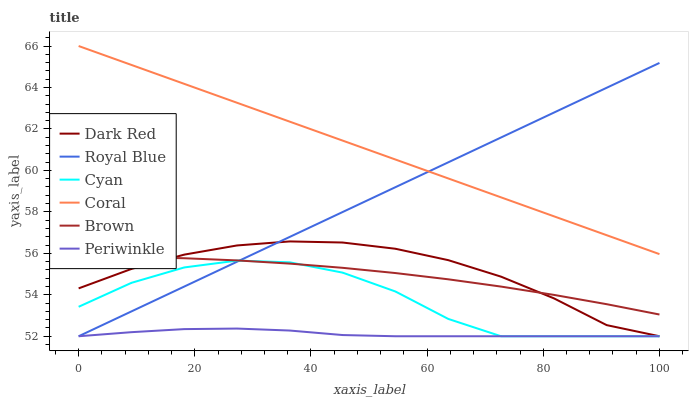Does Periwinkle have the minimum area under the curve?
Answer yes or no. Yes. Does Coral have the maximum area under the curve?
Answer yes or no. Yes. Does Dark Red have the minimum area under the curve?
Answer yes or no. No. Does Dark Red have the maximum area under the curve?
Answer yes or no. No. Is Royal Blue the smoothest?
Answer yes or no. Yes. Is Cyan the roughest?
Answer yes or no. Yes. Is Dark Red the smoothest?
Answer yes or no. No. Is Dark Red the roughest?
Answer yes or no. No. Does Dark Red have the lowest value?
Answer yes or no. Yes. Does Coral have the lowest value?
Answer yes or no. No. Does Coral have the highest value?
Answer yes or no. Yes. Does Dark Red have the highest value?
Answer yes or no. No. Is Dark Red less than Coral?
Answer yes or no. Yes. Is Coral greater than Periwinkle?
Answer yes or no. Yes. Does Dark Red intersect Royal Blue?
Answer yes or no. Yes. Is Dark Red less than Royal Blue?
Answer yes or no. No. Is Dark Red greater than Royal Blue?
Answer yes or no. No. Does Dark Red intersect Coral?
Answer yes or no. No. 